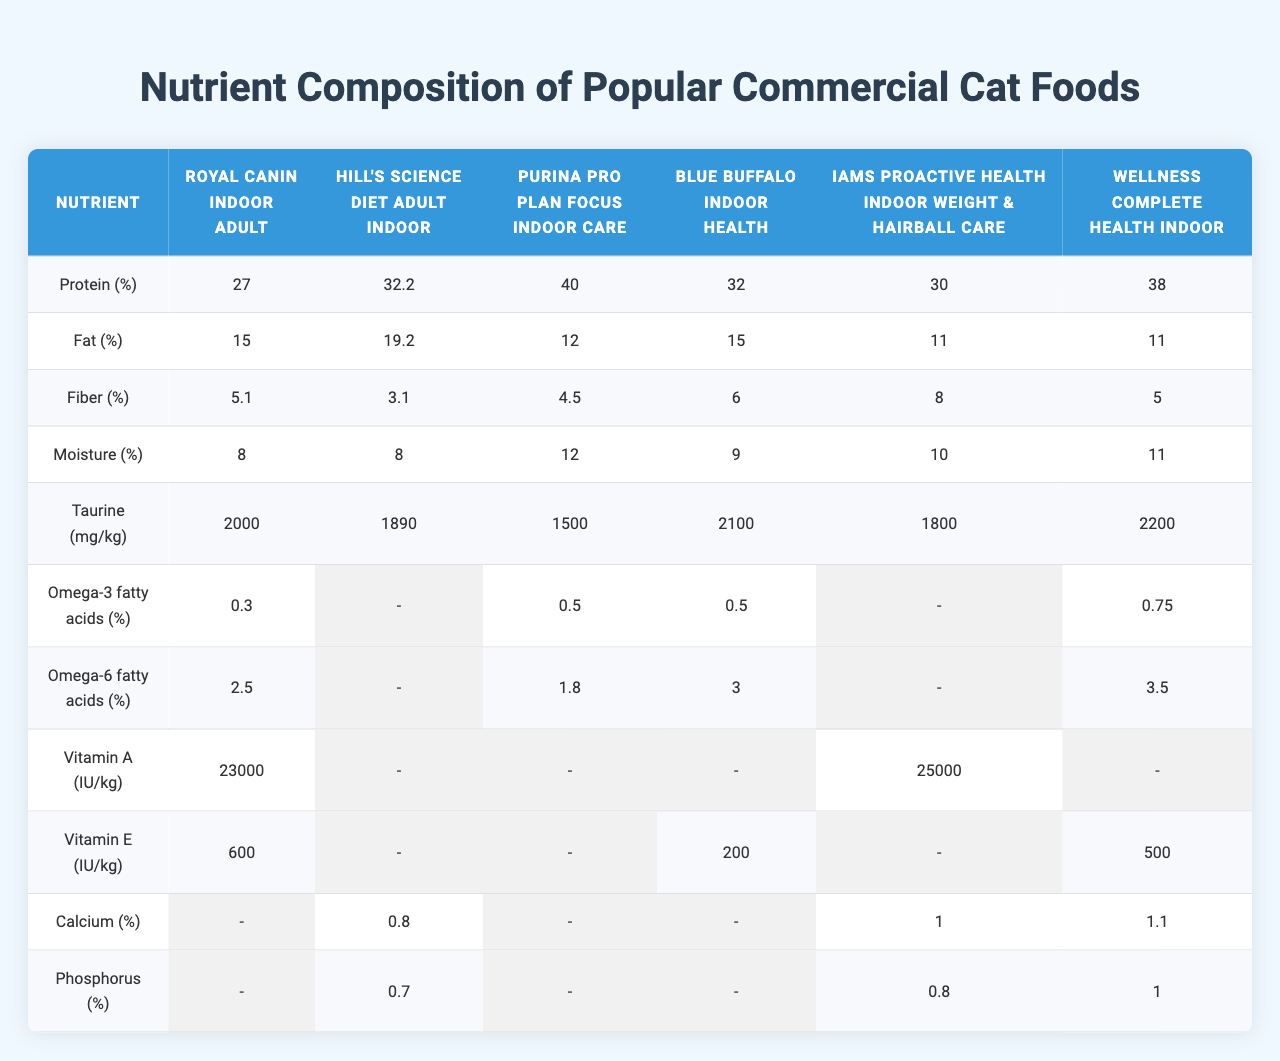What is the protein percentage in the Hill's Science Diet Adult Indoor? The table lists 32.2% for protein in Hill's Science Diet Adult Indoor.
Answer: 32.2% Which cat food has the highest fat percentage? The table shows that Hill's Science Diet Adult Indoor has the highest fat percentage at 19.2%.
Answer: Hill's Science Diet Adult Indoor What is the moisture percentage in Iams ProActive Health Indoor Weight & Hairball Care? The moisture percentage in Iams ProActive Health Indoor Weight & Hairball Care is listed as 10%.
Answer: 10% How much Taurine does the Wellness Complete Health Indoor contain? The table states that Wellness Complete Health Indoor contains 2200 mg/kg of Taurine.
Answer: 2200 mg/kg Which cat food contains Omega-6 fatty acids? The table indicates that all foods except for Hill's Science Diet Adult Indoor contain Omega-6 fatty acids.
Answer: Yes What is the difference in protein percentage between Purina Pro Plan Focus Indoor Care and Royal Canin Indoor Adult? Purina Pro Plan Focus has 40% protein, while Royal Canin has 27%. The difference is 40 - 27 = 13%.
Answer: 13% Calculate the average fat percentage across all listed cat foods. The fat percentages are 15, 19.2, 12, 15, 11, and 11. The total is 15 + 19.2 + 12 + 15 + 11 + 11 = 83.2, which divided by 6 gives an average of 13.87%.
Answer: 13.87% Which food has the lowest fiber percentage? The table shows that Hill's Science Diet Adult Indoor has the lowest fiber percentage at 3.1%.
Answer: 3.1% Is Vitamin E present in all cat foods? The table indicates that Vitamin E is only listed for Hill's Science Diet Adult Indoor, Blue Buffalo Indoor Health, and Wellness Complete Health Indoor, meaning it is not present in all foods.
Answer: No Which cat food has both the highest and lowest Omega-3 fatty acid percentages? The maximum Omega-3 is 0.75% in Wellness Complete Health Indoor, and the minimum is 0.3% in Royal Canin Indoor Adult. Thus, the highest is Wellness and the lowest is Royal Canin.
Answer: 0.75% and 0.3% respectively 